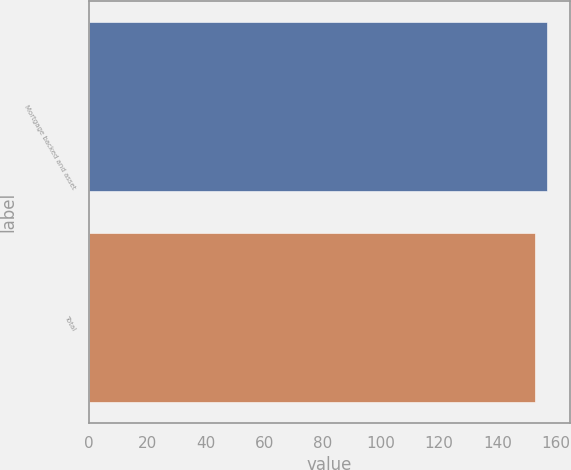<chart> <loc_0><loc_0><loc_500><loc_500><bar_chart><fcel>Mortgage backed and asset<fcel>Total<nl><fcel>157<fcel>153<nl></chart> 